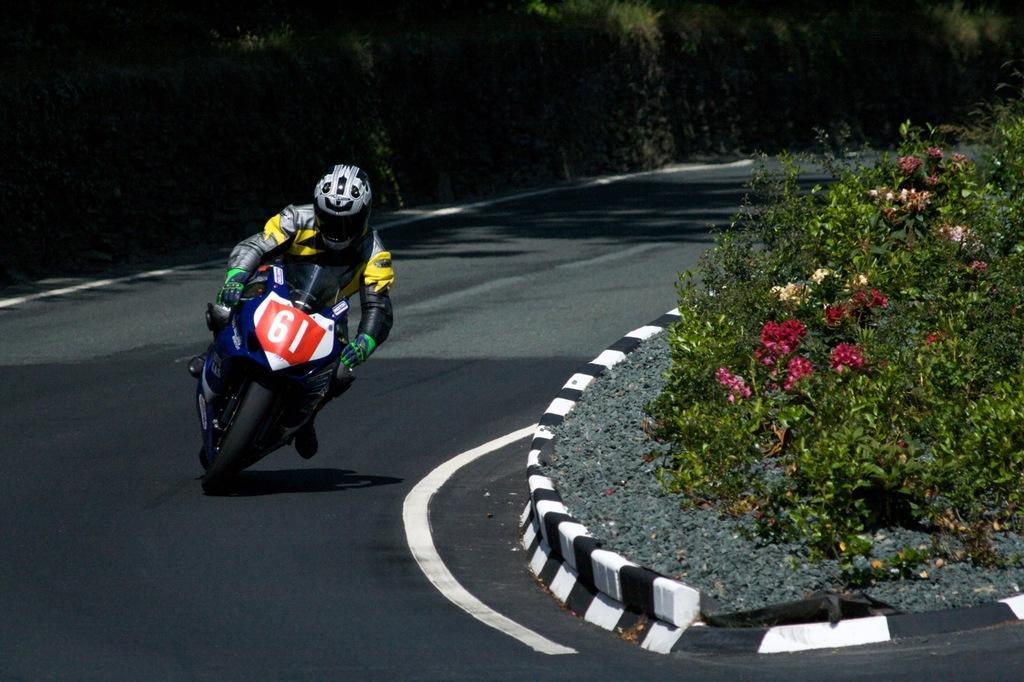Can you describe this image briefly? In this picture there is a man who is driving a bike on the road. On the right I can see some flowers on the plants. In the background I can see many trees. 